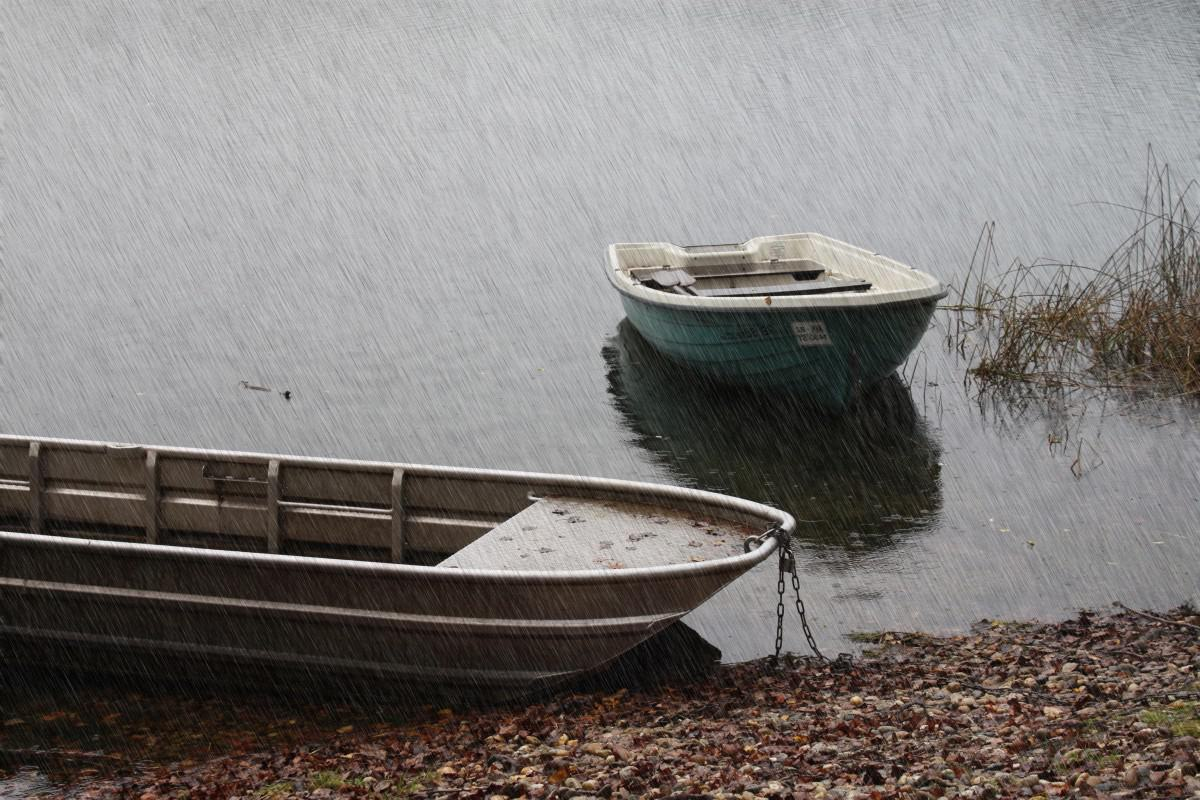How many boats are there in the image? The image shows two boats. One is closer to the shore and appears to be a small rowboat, secured by a chain to the land. The other is slightly further into the water and looks like a simple dinghy with an outboard at the stern. 